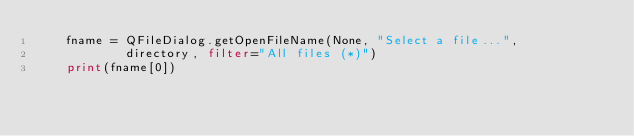Convert code to text. <code><loc_0><loc_0><loc_500><loc_500><_Python_>    fname = QFileDialog.getOpenFileName(None, "Select a file...", 
            directory, filter="All files (*)")
    print(fname[0])
</code> 